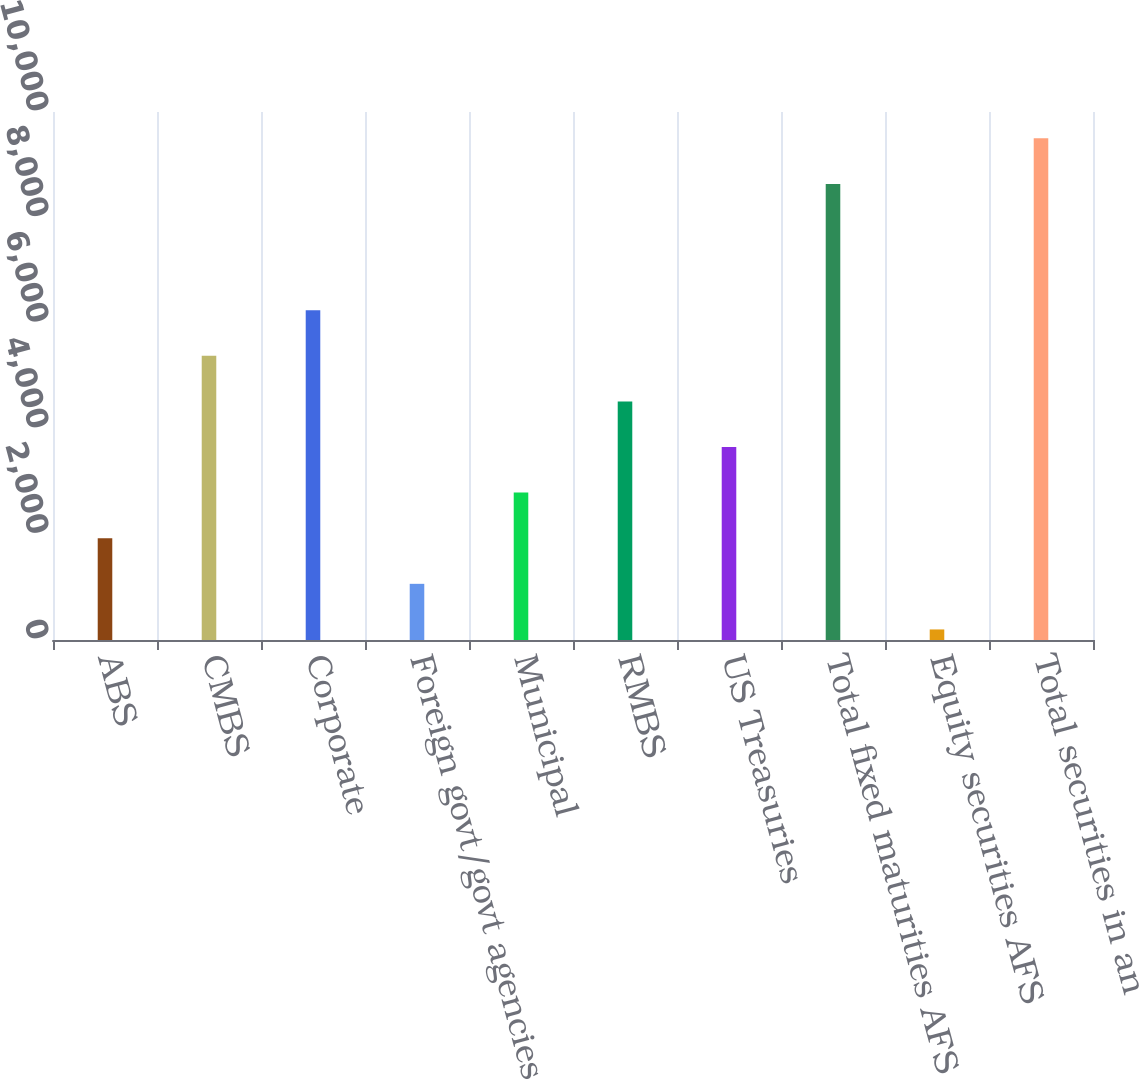<chart> <loc_0><loc_0><loc_500><loc_500><bar_chart><fcel>ABS<fcel>CMBS<fcel>Corporate<fcel>Foreign govt/govt agencies<fcel>Municipal<fcel>RMBS<fcel>US Treasuries<fcel>Total fixed maturities AFS<fcel>Equity securities AFS<fcel>Total securities in an<nl><fcel>1927.6<fcel>5382.8<fcel>6246.6<fcel>1063.8<fcel>2791.4<fcel>4519<fcel>3655.2<fcel>8638<fcel>200<fcel>9501.8<nl></chart> 